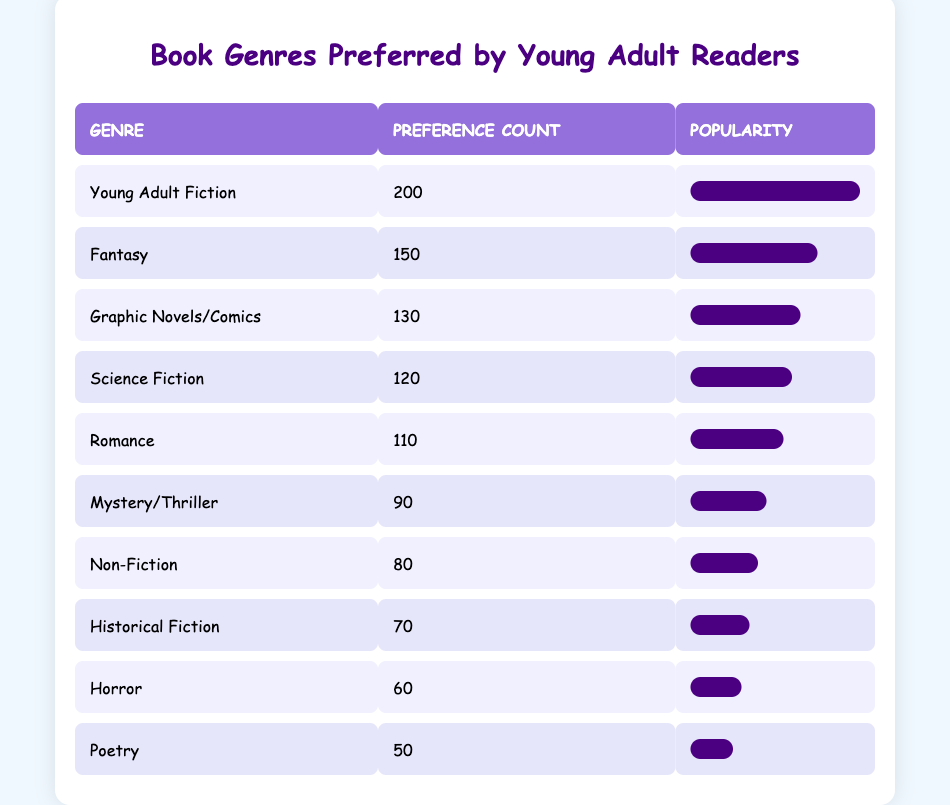What is the most preferred book genre among young adult readers? The table shows that "Young Adult Fiction" has a preference count of 200, which is the highest among all genres listed.
Answer: Young Adult Fiction How many readers prefer Fantasy over Horror? The preference count for Fantasy is 150, and for Horror, it is 60. To find how many more readers prefer Fantasy, we subtract the two counts: 150 - 60 = 90.
Answer: 90 Is Romance a more popular genre than Mystery/Thriller? Romance has a preference count of 110, while Mystery/Thriller has 90. Since 110 is greater than 90, we can conclude that Romance is more popular.
Answer: Yes What is the total preference count for the top three genres? The top three genres are Young Adult Fiction (200), Fantasy (150), and Graphic Novels/Comics (130). To find the total, we add these counts: 200 + 150 + 130 = 480.
Answer: 480 Which book genre has the least preference count, and what is that count? According to the table, Poetry has the least preference count at 50.
Answer: Poetry, 50 What is the average preference count of all genres listed in the table? To calculate the average, we first find the total preference count by summing up all genres: 200 + 150 + 130 + 120 + 110 + 90 + 80 + 70 + 60 + 50 = 1,060. Then, we divide by the number of genres (10): 1060 / 10 = 106.
Answer: 106 How many genres have a preference count over 100? The genres with counts over 100 are Young Adult Fiction (200), Fantasy (150), Graphic Novels/Comics (130), and Science Fiction (120). This makes a total of 4 genres.
Answer: 4 Is the preference count for Non-Fiction and Historical Fiction more than 150 combined? The counts for Non-Fiction and Historical Fiction are 80 and 70, respectively. To find the combined total, we add them: 80 + 70 = 150, which is not more than 150.
Answer: No What is the difference in preference count between the most and least preferred genres? The most preferred genre is Young Adult Fiction with 200, and the least preferred is Poetry with 50. To find the difference, we subtract: 200 - 50 = 150.
Answer: 150 